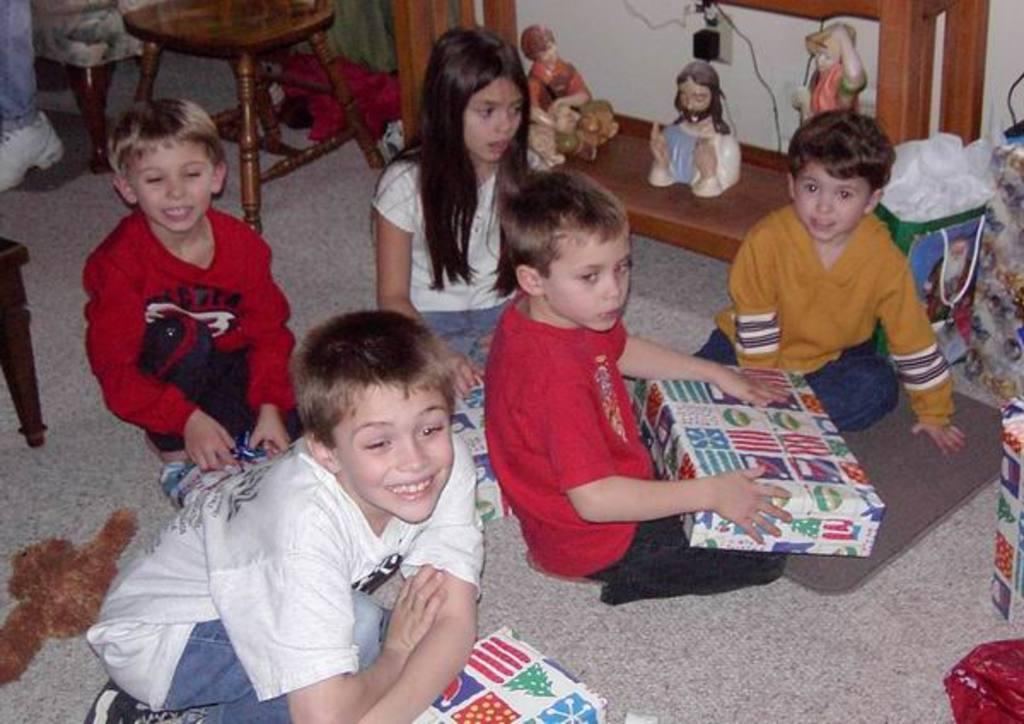What are the children doing in the image? The children are on the floor in the image. What is one child holding in the image? A child is holding a box in the image. What can be seen on the floor besides the children? There are objects on the floor in the image. What type of furniture is present in the image? There is a stool in the image. What is on the table in the image? There are statues on a table in the image. What type of cable is being used by the children to fly planes in the image? There is no cable or planes present in the image; the children are simply on the floor and holding a box. 